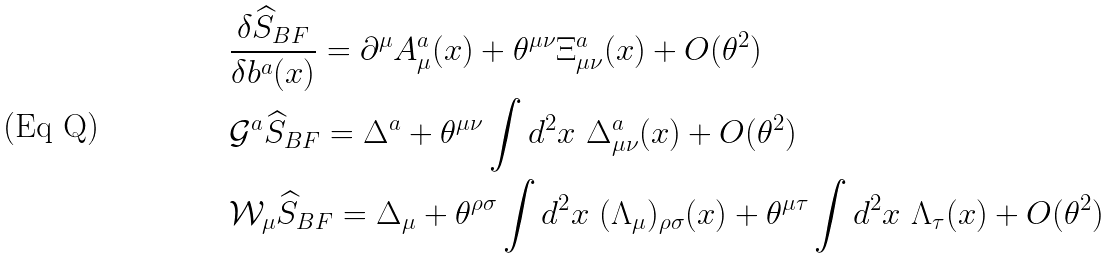Convert formula to latex. <formula><loc_0><loc_0><loc_500><loc_500>& \frac { \delta \widehat { S } _ { B F } } { \delta b ^ { a } ( x ) } = \partial ^ { \mu } A _ { \mu } ^ { a } ( x ) + \theta ^ { \mu \nu } \Xi _ { \mu \nu } ^ { a } ( x ) + O ( \theta ^ { 2 } ) \\ & \mathcal { G } ^ { a } \widehat { S } _ { B F } = \Delta ^ { a } + \theta ^ { \mu \nu } \int d ^ { 2 } x \ \Delta _ { \mu \nu } ^ { a } ( x ) + O ( \theta ^ { 2 } ) \\ & \mathcal { W } _ { \mu } \widehat { S } _ { B F } = \Delta _ { \mu } + \theta ^ { \rho \sigma } \int d ^ { 2 } x \ ( \Lambda _ { \mu } ) _ { \rho \sigma } ( x ) + \theta ^ { \mu \tau } \int d ^ { 2 } x \ \Lambda _ { \tau } ( x ) + O ( \theta ^ { 2 } )</formula> 